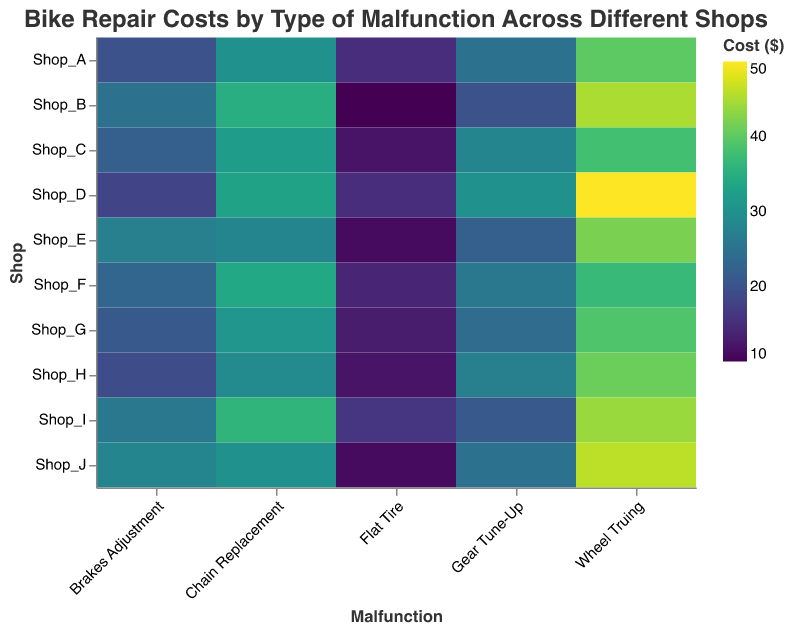What is the cost of a flat tire repair at Shop_B? Look at the row for Shop_B and the column for Flat Tire. The value at the intersection is the cost.
Answer: 10 Which shop charges the most for gear tune-up? Find the column for Gear Tune-Up and look for the highest cost across all shops. Shop_D charges the most with a cost of 30.
Answer: Shop_D How much more does Shop_E charge for brakes adjustment compared to Shop_H? Compare the cost of Brakes Adjustment in Shop_E and Shop_H. Shop_E charges 27, and Shop_H charges 19. The difference is 27 - 19.
Answer: 8 What is the average cost for chain replacement across all shops? Sum the costs for Chain Replacement across all shops and divide by the number of shops (10). The sum is 30+35+32+33+28+34+31+29+36+30 = 318, so the average is 318/10.
Answer: 31.8 Which shop has the lowest cost for wheel truing, and what is the cost? Look at the column for Wheel Truing and find the lowest value, which is 37 in Shop_F.
Answer: Shop_F, 37 What is the range of costs for flat tires among all shops? Identify the maximum and minimum costs for Flat Tires across all shops. The maximum is 16 (Shop_I) and the minimum is 10 (Shop_B), so the range is 16 - 10.
Answer: 6 Is there any shop that charges the same for gear tune-up as for chain replacement? Compare the costs for Gear Tune-Up and Chain Replacement within each shop. No shop has the same cost for both services.
Answer: No How does the cost of wheel truing at Shop_A compare to the cost at Shop_J? Compare the costs for Wheel Truing in Shop_A and Shop_J. Shop_A charges 40 and Shop_J charges 46. Shop_A charges 6 less than Shop_J.
Answer: 6 less 